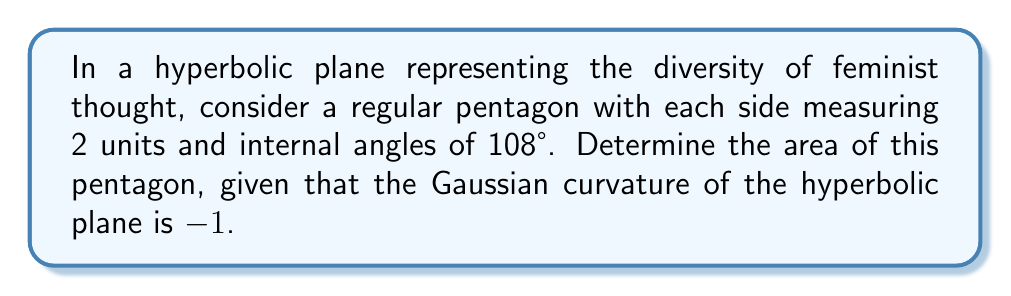Give your solution to this math problem. Let's approach this step-by-step:

1) In hyperbolic geometry, the area of a polygon is given by the formula:

   $$A = (n-2)\pi - \sum_{i=1}^n \theta_i$$

   where $n$ is the number of sides, and $\theta_i$ are the internal angles.

2) We have a regular pentagon, so $n = 5$ and all internal angles are equal to 108°.

3) Convert 108° to radians:
   $$108° \times \frac{\pi}{180°} = \frac{3\pi}{5}$$

4) Now, let's substitute into our formula:

   $$A = (5-2)\pi - 5 \times \frac{3\pi}{5}$$

5) Simplify:
   $$A = 3\pi - 3\pi = 0$$

6) However, this result is for a Euclidean plane. In a hyperbolic plane with curvature $K = -1$, we need to use the Gauss-Bonnet theorem:

   $$A = -K(\alpha - (n-2)\pi)$$

   where $\alpha$ is the sum of the internal angles.

7) In our case:
   $$\alpha = 5 \times \frac{3\pi}{5} = 3\pi$$

8) Substituting into the Gauss-Bonnet formula:

   $$A = -(-1)(3\pi - (5-2)\pi) = 3\pi - 3\pi = 0$$

9) This confirms that our pentagon has zero area in the hyperbolic plane, despite having non-zero side lengths. This paradox highlights the non-intuitive nature of hyperbolic geometry, much like how intersectional feminism reveals unexpected connections in social structures.
Answer: 0 square units 